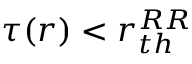<formula> <loc_0><loc_0><loc_500><loc_500>\tau ( r ) < r _ { t h } ^ { R R }</formula> 